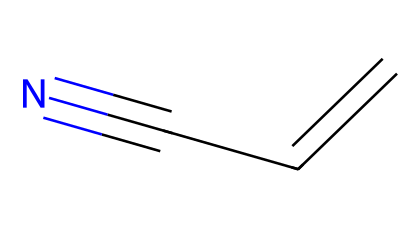What is the molecular formula of acrylonitrile? The SMILES representation indicates the presence of three carbon atoms (C), one nitrogen atom (N), and four hydrogen atoms (H). Thus, the molecular formula can be deduced as C3H3N.
Answer: C3H3N How many double bonds are present in acrylonitrile? In the SMILES notation, "C=C" indicates one double bond between two carbon atoms. Therefore, there is one double bond in the structure.
Answer: 1 How many carbon atoms are in the structure of acrylonitrile? By analyzing the SMILES representation, there are three 'C' symbols present, indicating three carbon atoms in the molecule.
Answer: 3 What functional group is present in acrylonitrile? The presence of the cyano group (-C≡N), which consists of a carbon triple-bonded to a nitrogen, identifies this compound as a nitrile.
Answer: nitrile What type of isomerism might acrylonitrile exhibit? Given that acrylonitrile contains a double bond, it can exhibit geometric isomerism (cis/trans) due to its C=C bond, leading to the possibility of different spatial arrangements.
Answer: geometric Why does acrylonitrile have a low boiling point compared to alkanes? The presence of the polar nitrile functional group contributes to dipole-dipole interactions, but the overall molecular weight is lower compared to corresponding alkanes, resulting in a lower boiling point due to weaker van der Waals forces compared to similar size alkanes.
Answer: lower boiling point How does the structure of acrylonitrile facilitate its use in synthetic fibers? The presence of a double bond allows for polymerization, which is essential for forming long-chain polymers required in synthetic fibers. Moreover, the cyano group provides additional functionality that enhances adherence and compatibility in fibers.
Answer: polymerization 